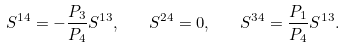<formula> <loc_0><loc_0><loc_500><loc_500>S ^ { 1 4 } = - \frac { P _ { 3 } } { P _ { 4 } } S ^ { 1 3 } , \quad S ^ { 2 4 } = 0 , \quad S ^ { 3 4 } = \frac { P _ { 1 } } { P _ { 4 } } S ^ { 1 3 } .</formula> 